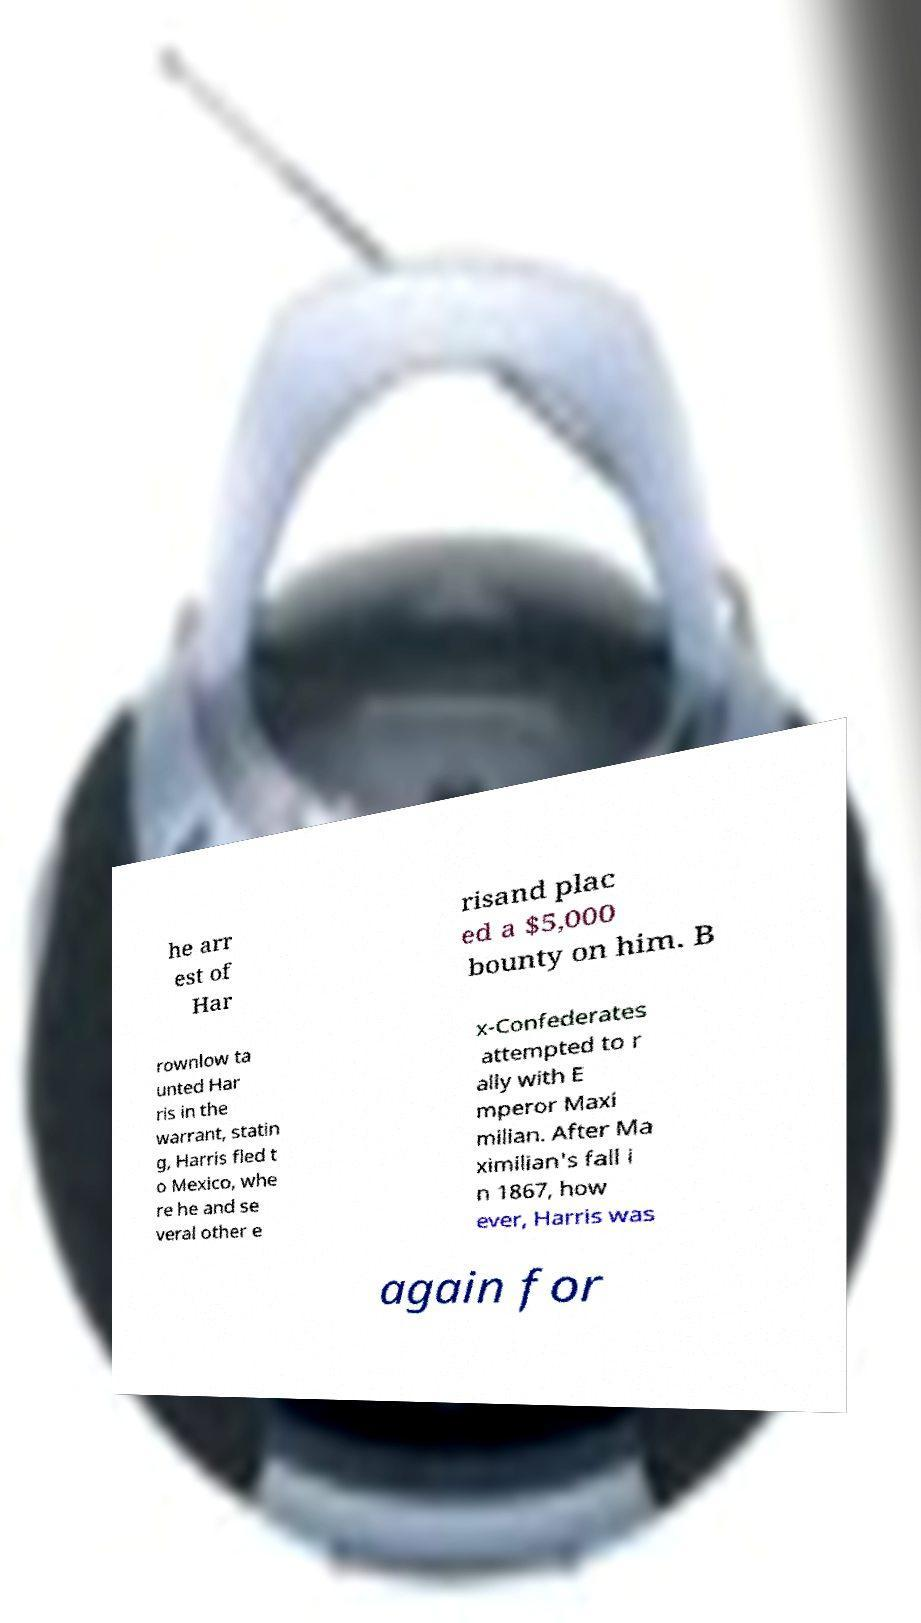For documentation purposes, I need the text within this image transcribed. Could you provide that? he arr est of Har risand plac ed a $5,000 bounty on him. B rownlow ta unted Har ris in the warrant, statin g, Harris fled t o Mexico, whe re he and se veral other e x-Confederates attempted to r ally with E mperor Maxi milian. After Ma ximilian's fall i n 1867, how ever, Harris was again for 